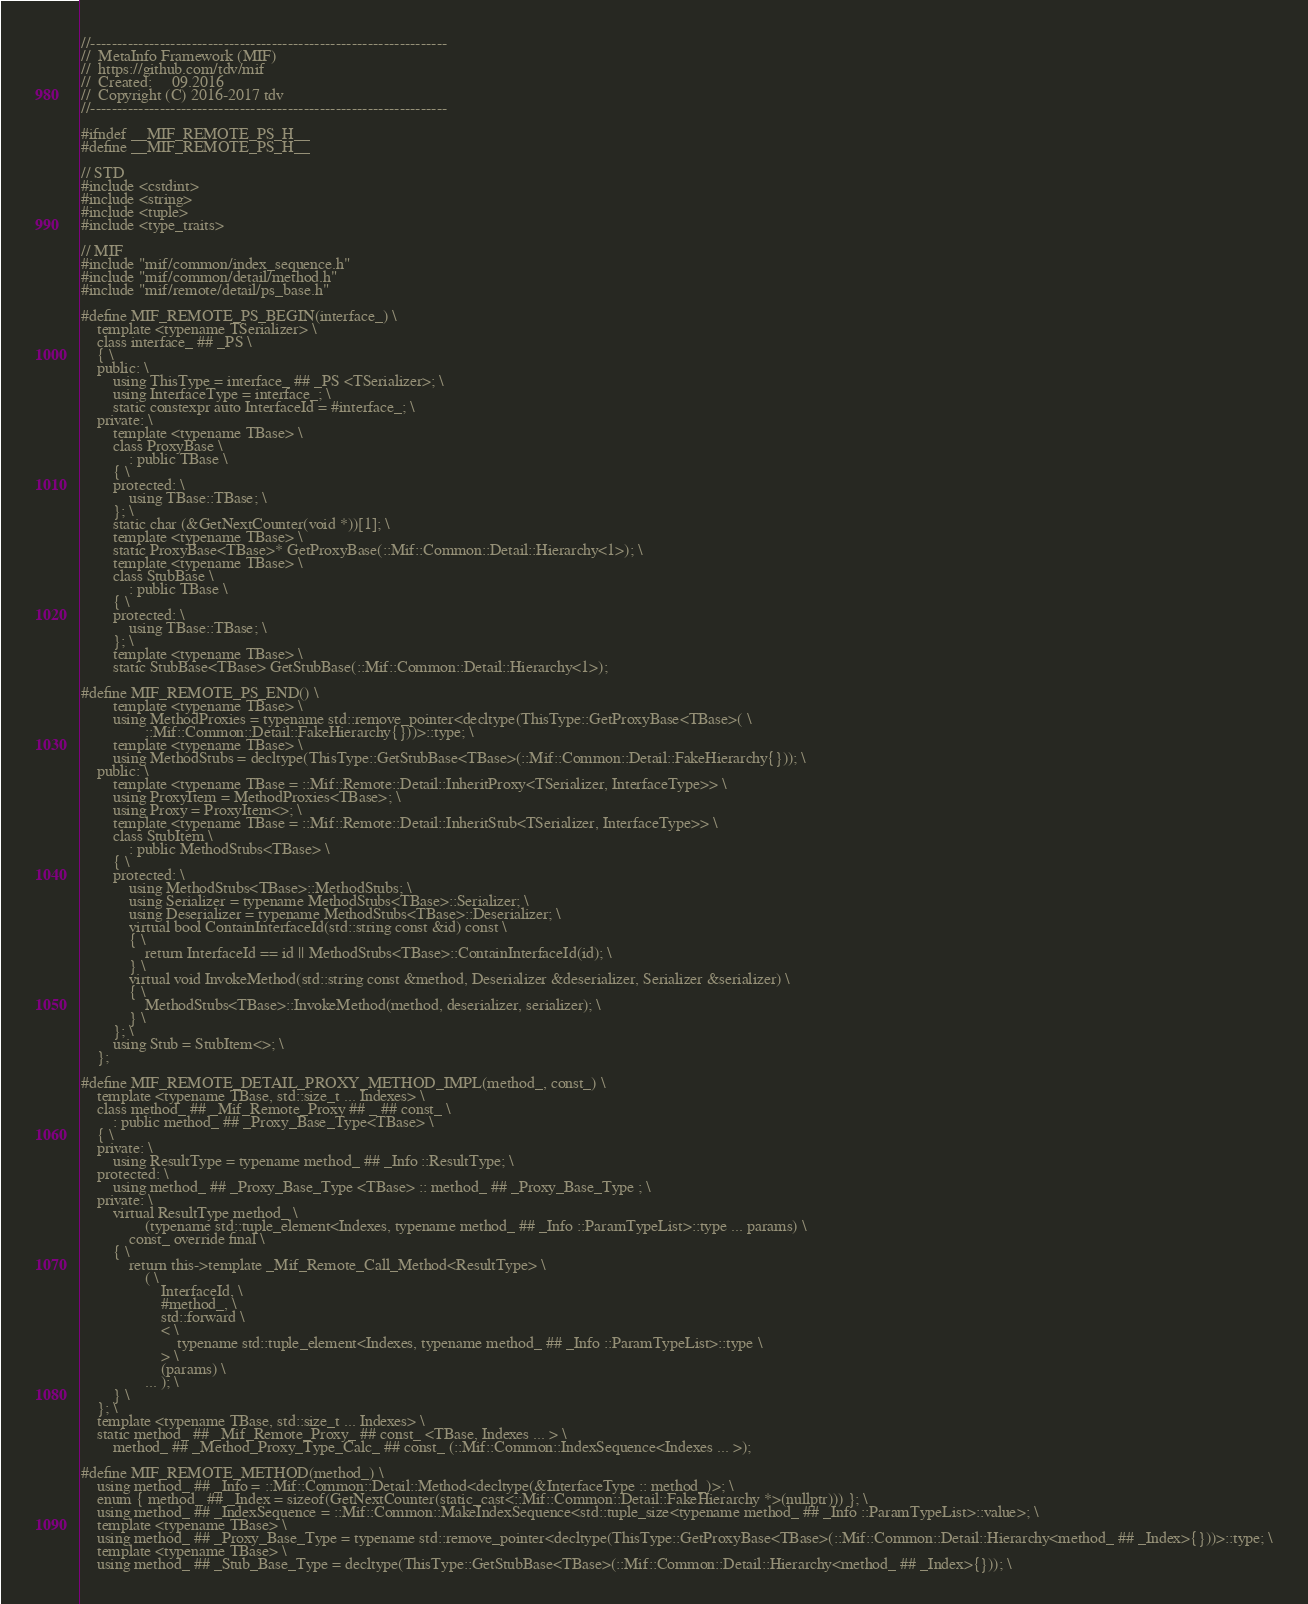<code> <loc_0><loc_0><loc_500><loc_500><_C_>//-------------------------------------------------------------------
//  MetaInfo Framework (MIF)
//  https://github.com/tdv/mif
//  Created:     09.2016
//  Copyright (C) 2016-2017 tdv
//-------------------------------------------------------------------

#ifndef __MIF_REMOTE_PS_H__
#define __MIF_REMOTE_PS_H__

// STD
#include <cstdint>
#include <string>
#include <tuple>
#include <type_traits>

// MIF
#include "mif/common/index_sequence.h"
#include "mif/common/detail/method.h"
#include "mif/remote/detail/ps_base.h"

#define MIF_REMOTE_PS_BEGIN(interface_) \
    template <typename TSerializer> \
    class interface_ ## _PS \
    { \
    public: \
        using ThisType = interface_ ## _PS <TSerializer>; \
        using InterfaceType = interface_; \
        static constexpr auto InterfaceId = #interface_; \
    private: \
        template <typename TBase> \
        class ProxyBase \
            : public TBase \
        { \
        protected: \
            using TBase::TBase; \
        }; \
        static char (&GetNextCounter(void *))[1]; \
        template <typename TBase> \
        static ProxyBase<TBase>* GetProxyBase(::Mif::Common::Detail::Hierarchy<1>); \
        template <typename TBase> \
        class StubBase \
            : public TBase \
        { \
        protected: \
            using TBase::TBase; \
        }; \
        template <typename TBase> \
        static StubBase<TBase> GetStubBase(::Mif::Common::Detail::Hierarchy<1>);

#define MIF_REMOTE_PS_END() \
        template <typename TBase> \
        using MethodProxies = typename std::remove_pointer<decltype(ThisType::GetProxyBase<TBase>( \
                ::Mif::Common::Detail::FakeHierarchy{}))>::type; \
        template <typename TBase> \
        using MethodStubs = decltype(ThisType::GetStubBase<TBase>(::Mif::Common::Detail::FakeHierarchy{})); \
    public: \
        template <typename TBase = ::Mif::Remote::Detail::InheritProxy<TSerializer, InterfaceType>> \
        using ProxyItem = MethodProxies<TBase>; \
        using Proxy = ProxyItem<>; \
        template <typename TBase = ::Mif::Remote::Detail::InheritStub<TSerializer, InterfaceType>> \
        class StubItem \
            : public MethodStubs<TBase> \
        { \
        protected: \
            using MethodStubs<TBase>::MethodStubs; \
            using Serializer = typename MethodStubs<TBase>::Serializer; \
            using Deserializer = typename MethodStubs<TBase>::Deserializer; \
            virtual bool ContainInterfaceId(std::string const &id) const \
            { \
                return InterfaceId == id || MethodStubs<TBase>::ContainInterfaceId(id); \
            } \
            virtual void InvokeMethod(std::string const &method, Deserializer &deserializer, Serializer &serializer) \
            { \
                MethodStubs<TBase>::InvokeMethod(method, deserializer, serializer); \
            } \
        }; \
        using Stub = StubItem<>; \
    };

#define MIF_REMOTE_DETAIL_PROXY_METHOD_IMPL(method_, const_) \
    template <typename TBase, std::size_t ... Indexes> \
    class method_ ## _Mif_Remote_Proxy ## _ ## const_ \
        : public method_ ## _Proxy_Base_Type<TBase> \
    { \
    private: \
        using ResultType = typename method_ ## _Info ::ResultType; \
    protected: \
        using method_ ## _Proxy_Base_Type <TBase> :: method_ ## _Proxy_Base_Type ; \
    private: \
        virtual ResultType method_ \
                (typename std::tuple_element<Indexes, typename method_ ## _Info ::ParamTypeList>::type ... params) \
            const_ override final \
        { \
            return this->template _Mif_Remote_Call_Method<ResultType> \
                ( \
                    InterfaceId, \
                    #method_, \
                    std::forward \
                    < \
                        typename std::tuple_element<Indexes, typename method_ ## _Info ::ParamTypeList>::type \
                    > \
                    (params) \
                ... ); \
        } \
    }; \
    template <typename TBase, std::size_t ... Indexes> \
    static method_ ## _Mif_Remote_Proxy_ ## const_ <TBase, Indexes ... > \
        method_ ## _Method_Proxy_Type_Calc_ ## const_ (::Mif::Common::IndexSequence<Indexes ... >);

#define MIF_REMOTE_METHOD(method_) \
    using method_ ## _Info = ::Mif::Common::Detail::Method<decltype(&InterfaceType :: method_)>; \
    enum { method_ ## _Index = sizeof(GetNextCounter(static_cast<::Mif::Common::Detail::FakeHierarchy *>(nullptr))) }; \
    using method_ ## _IndexSequence = ::Mif::Common::MakeIndexSequence<std::tuple_size<typename method_ ## _Info ::ParamTypeList>::value>; \
    template <typename TBase> \
    using method_ ## _Proxy_Base_Type = typename std::remove_pointer<decltype(ThisType::GetProxyBase<TBase>(::Mif::Common::Detail::Hierarchy<method_ ## _Index>{}))>::type; \
    template <typename TBase> \
    using method_ ## _Stub_Base_Type = decltype(ThisType::GetStubBase<TBase>(::Mif::Common::Detail::Hierarchy<method_ ## _Index>{})); \</code> 